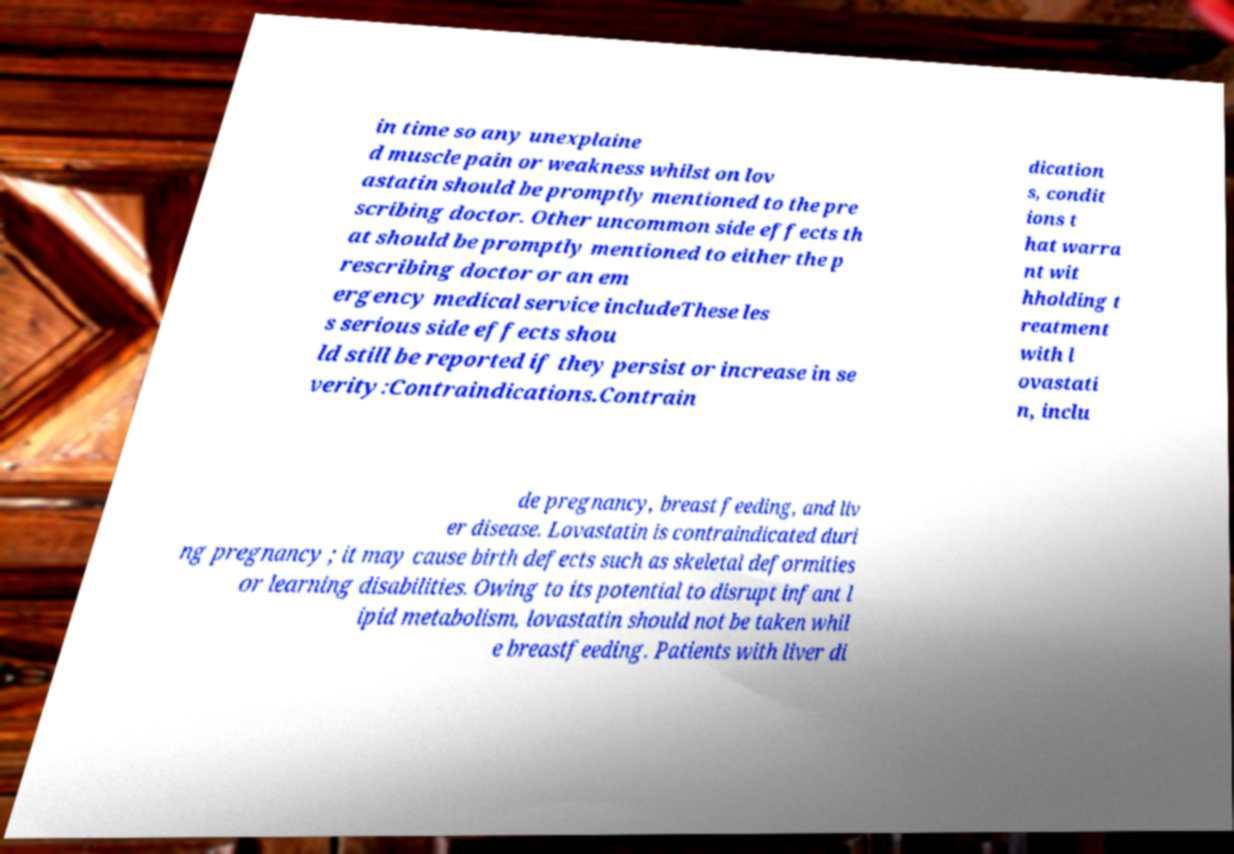Could you assist in decoding the text presented in this image and type it out clearly? in time so any unexplaine d muscle pain or weakness whilst on lov astatin should be promptly mentioned to the pre scribing doctor. Other uncommon side effects th at should be promptly mentioned to either the p rescribing doctor or an em ergency medical service includeThese les s serious side effects shou ld still be reported if they persist or increase in se verity:Contraindications.Contrain dication s, condit ions t hat warra nt wit hholding t reatment with l ovastati n, inclu de pregnancy, breast feeding, and liv er disease. Lovastatin is contraindicated duri ng pregnancy ; it may cause birth defects such as skeletal deformities or learning disabilities. Owing to its potential to disrupt infant l ipid metabolism, lovastatin should not be taken whil e breastfeeding. Patients with liver di 